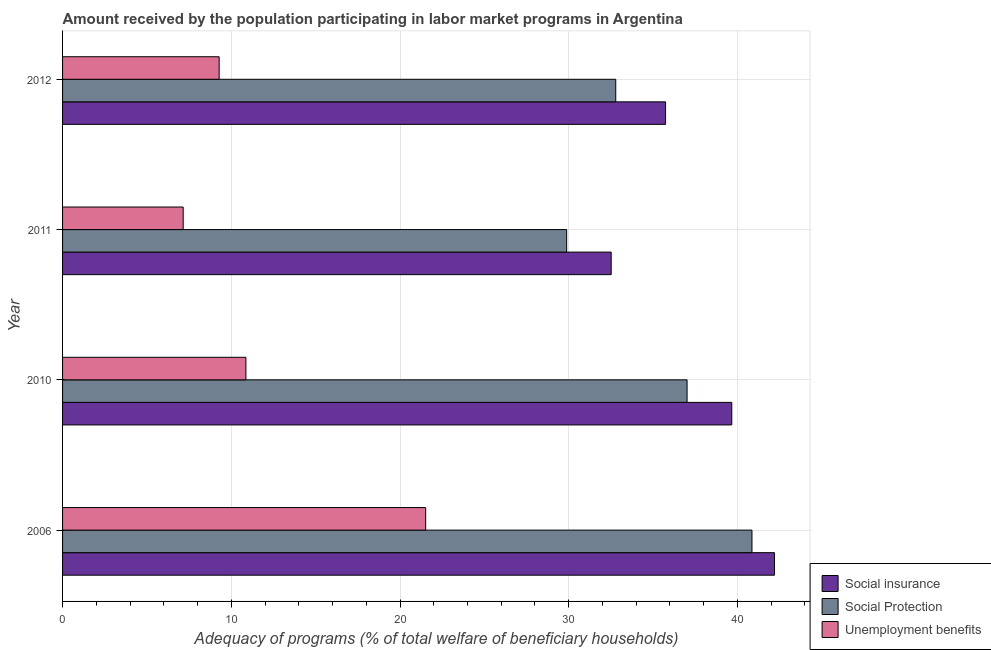How many different coloured bars are there?
Give a very brief answer. 3. Are the number of bars per tick equal to the number of legend labels?
Give a very brief answer. Yes. How many bars are there on the 4th tick from the bottom?
Keep it short and to the point. 3. What is the label of the 2nd group of bars from the top?
Give a very brief answer. 2011. What is the amount received by the population participating in social protection programs in 2006?
Provide a short and direct response. 40.86. Across all years, what is the maximum amount received by the population participating in social protection programs?
Offer a very short reply. 40.86. Across all years, what is the minimum amount received by the population participating in unemployment benefits programs?
Offer a terse response. 7.15. In which year was the amount received by the population participating in unemployment benefits programs minimum?
Ensure brevity in your answer.  2011. What is the total amount received by the population participating in unemployment benefits programs in the graph?
Offer a very short reply. 48.82. What is the difference between the amount received by the population participating in social insurance programs in 2006 and that in 2010?
Offer a terse response. 2.53. What is the difference between the amount received by the population participating in social insurance programs in 2011 and the amount received by the population participating in unemployment benefits programs in 2012?
Your answer should be very brief. 23.23. What is the average amount received by the population participating in social protection programs per year?
Keep it short and to the point. 35.13. In the year 2012, what is the difference between the amount received by the population participating in social protection programs and amount received by the population participating in social insurance programs?
Your response must be concise. -2.95. What is the ratio of the amount received by the population participating in unemployment benefits programs in 2006 to that in 2011?
Keep it short and to the point. 3.01. What is the difference between the highest and the second highest amount received by the population participating in unemployment benefits programs?
Give a very brief answer. 10.65. What is the difference between the highest and the lowest amount received by the population participating in social insurance programs?
Your response must be concise. 9.68. In how many years, is the amount received by the population participating in social insurance programs greater than the average amount received by the population participating in social insurance programs taken over all years?
Keep it short and to the point. 2. Is the sum of the amount received by the population participating in social insurance programs in 2010 and 2011 greater than the maximum amount received by the population participating in social protection programs across all years?
Ensure brevity in your answer.  Yes. What does the 1st bar from the top in 2012 represents?
Make the answer very short. Unemployment benefits. What does the 2nd bar from the bottom in 2006 represents?
Keep it short and to the point. Social Protection. Is it the case that in every year, the sum of the amount received by the population participating in social insurance programs and amount received by the population participating in social protection programs is greater than the amount received by the population participating in unemployment benefits programs?
Your answer should be very brief. Yes. How many bars are there?
Offer a terse response. 12. Are all the bars in the graph horizontal?
Make the answer very short. Yes. Where does the legend appear in the graph?
Your answer should be very brief. Bottom right. How many legend labels are there?
Ensure brevity in your answer.  3. How are the legend labels stacked?
Offer a terse response. Vertical. What is the title of the graph?
Ensure brevity in your answer.  Amount received by the population participating in labor market programs in Argentina. What is the label or title of the X-axis?
Provide a succinct answer. Adequacy of programs (% of total welfare of beneficiary households). What is the label or title of the Y-axis?
Make the answer very short. Year. What is the Adequacy of programs (% of total welfare of beneficiary households) in Social insurance in 2006?
Give a very brief answer. 42.2. What is the Adequacy of programs (% of total welfare of beneficiary households) in Social Protection in 2006?
Give a very brief answer. 40.86. What is the Adequacy of programs (% of total welfare of beneficiary households) in Unemployment benefits in 2006?
Make the answer very short. 21.52. What is the Adequacy of programs (% of total welfare of beneficiary households) in Social insurance in 2010?
Give a very brief answer. 39.66. What is the Adequacy of programs (% of total welfare of beneficiary households) in Social Protection in 2010?
Provide a succinct answer. 37.01. What is the Adequacy of programs (% of total welfare of beneficiary households) of Unemployment benefits in 2010?
Provide a succinct answer. 10.87. What is the Adequacy of programs (% of total welfare of beneficiary households) in Social insurance in 2011?
Offer a very short reply. 32.52. What is the Adequacy of programs (% of total welfare of beneficiary households) in Social Protection in 2011?
Provide a short and direct response. 29.88. What is the Adequacy of programs (% of total welfare of beneficiary households) of Unemployment benefits in 2011?
Make the answer very short. 7.15. What is the Adequacy of programs (% of total welfare of beneficiary households) in Social insurance in 2012?
Provide a short and direct response. 35.74. What is the Adequacy of programs (% of total welfare of beneficiary households) of Social Protection in 2012?
Provide a succinct answer. 32.79. What is the Adequacy of programs (% of total welfare of beneficiary households) in Unemployment benefits in 2012?
Make the answer very short. 9.28. Across all years, what is the maximum Adequacy of programs (% of total welfare of beneficiary households) in Social insurance?
Offer a terse response. 42.2. Across all years, what is the maximum Adequacy of programs (% of total welfare of beneficiary households) in Social Protection?
Your answer should be very brief. 40.86. Across all years, what is the maximum Adequacy of programs (% of total welfare of beneficiary households) in Unemployment benefits?
Ensure brevity in your answer.  21.52. Across all years, what is the minimum Adequacy of programs (% of total welfare of beneficiary households) in Social insurance?
Give a very brief answer. 32.52. Across all years, what is the minimum Adequacy of programs (% of total welfare of beneficiary households) of Social Protection?
Your answer should be compact. 29.88. Across all years, what is the minimum Adequacy of programs (% of total welfare of beneficiary households) in Unemployment benefits?
Your answer should be compact. 7.15. What is the total Adequacy of programs (% of total welfare of beneficiary households) in Social insurance in the graph?
Your answer should be compact. 150.11. What is the total Adequacy of programs (% of total welfare of beneficiary households) of Social Protection in the graph?
Make the answer very short. 140.54. What is the total Adequacy of programs (% of total welfare of beneficiary households) of Unemployment benefits in the graph?
Your response must be concise. 48.82. What is the difference between the Adequacy of programs (% of total welfare of beneficiary households) in Social insurance in 2006 and that in 2010?
Ensure brevity in your answer.  2.53. What is the difference between the Adequacy of programs (% of total welfare of beneficiary households) in Social Protection in 2006 and that in 2010?
Keep it short and to the point. 3.85. What is the difference between the Adequacy of programs (% of total welfare of beneficiary households) of Unemployment benefits in 2006 and that in 2010?
Keep it short and to the point. 10.65. What is the difference between the Adequacy of programs (% of total welfare of beneficiary households) in Social insurance in 2006 and that in 2011?
Provide a succinct answer. 9.68. What is the difference between the Adequacy of programs (% of total welfare of beneficiary households) of Social Protection in 2006 and that in 2011?
Make the answer very short. 10.98. What is the difference between the Adequacy of programs (% of total welfare of beneficiary households) of Unemployment benefits in 2006 and that in 2011?
Offer a very short reply. 14.37. What is the difference between the Adequacy of programs (% of total welfare of beneficiary households) in Social insurance in 2006 and that in 2012?
Your response must be concise. 6.46. What is the difference between the Adequacy of programs (% of total welfare of beneficiary households) in Social Protection in 2006 and that in 2012?
Give a very brief answer. 8.07. What is the difference between the Adequacy of programs (% of total welfare of beneficiary households) in Unemployment benefits in 2006 and that in 2012?
Offer a very short reply. 12.24. What is the difference between the Adequacy of programs (% of total welfare of beneficiary households) in Social insurance in 2010 and that in 2011?
Provide a succinct answer. 7.15. What is the difference between the Adequacy of programs (% of total welfare of beneficiary households) in Social Protection in 2010 and that in 2011?
Offer a terse response. 7.14. What is the difference between the Adequacy of programs (% of total welfare of beneficiary households) of Unemployment benefits in 2010 and that in 2011?
Offer a very short reply. 3.72. What is the difference between the Adequacy of programs (% of total welfare of beneficiary households) of Social insurance in 2010 and that in 2012?
Your answer should be very brief. 3.92. What is the difference between the Adequacy of programs (% of total welfare of beneficiary households) in Social Protection in 2010 and that in 2012?
Make the answer very short. 4.23. What is the difference between the Adequacy of programs (% of total welfare of beneficiary households) of Unemployment benefits in 2010 and that in 2012?
Provide a succinct answer. 1.59. What is the difference between the Adequacy of programs (% of total welfare of beneficiary households) in Social insurance in 2011 and that in 2012?
Your answer should be compact. -3.22. What is the difference between the Adequacy of programs (% of total welfare of beneficiary households) of Social Protection in 2011 and that in 2012?
Make the answer very short. -2.91. What is the difference between the Adequacy of programs (% of total welfare of beneficiary households) of Unemployment benefits in 2011 and that in 2012?
Your answer should be very brief. -2.13. What is the difference between the Adequacy of programs (% of total welfare of beneficiary households) of Social insurance in 2006 and the Adequacy of programs (% of total welfare of beneficiary households) of Social Protection in 2010?
Your answer should be very brief. 5.18. What is the difference between the Adequacy of programs (% of total welfare of beneficiary households) of Social insurance in 2006 and the Adequacy of programs (% of total welfare of beneficiary households) of Unemployment benefits in 2010?
Your answer should be very brief. 31.33. What is the difference between the Adequacy of programs (% of total welfare of beneficiary households) of Social Protection in 2006 and the Adequacy of programs (% of total welfare of beneficiary households) of Unemployment benefits in 2010?
Ensure brevity in your answer.  29.99. What is the difference between the Adequacy of programs (% of total welfare of beneficiary households) of Social insurance in 2006 and the Adequacy of programs (% of total welfare of beneficiary households) of Social Protection in 2011?
Provide a succinct answer. 12.32. What is the difference between the Adequacy of programs (% of total welfare of beneficiary households) of Social insurance in 2006 and the Adequacy of programs (% of total welfare of beneficiary households) of Unemployment benefits in 2011?
Provide a succinct answer. 35.05. What is the difference between the Adequacy of programs (% of total welfare of beneficiary households) in Social Protection in 2006 and the Adequacy of programs (% of total welfare of beneficiary households) in Unemployment benefits in 2011?
Provide a succinct answer. 33.71. What is the difference between the Adequacy of programs (% of total welfare of beneficiary households) of Social insurance in 2006 and the Adequacy of programs (% of total welfare of beneficiary households) of Social Protection in 2012?
Offer a terse response. 9.41. What is the difference between the Adequacy of programs (% of total welfare of beneficiary households) of Social insurance in 2006 and the Adequacy of programs (% of total welfare of beneficiary households) of Unemployment benefits in 2012?
Offer a terse response. 32.91. What is the difference between the Adequacy of programs (% of total welfare of beneficiary households) in Social Protection in 2006 and the Adequacy of programs (% of total welfare of beneficiary households) in Unemployment benefits in 2012?
Your response must be concise. 31.58. What is the difference between the Adequacy of programs (% of total welfare of beneficiary households) in Social insurance in 2010 and the Adequacy of programs (% of total welfare of beneficiary households) in Social Protection in 2011?
Make the answer very short. 9.79. What is the difference between the Adequacy of programs (% of total welfare of beneficiary households) in Social insurance in 2010 and the Adequacy of programs (% of total welfare of beneficiary households) in Unemployment benefits in 2011?
Offer a terse response. 32.51. What is the difference between the Adequacy of programs (% of total welfare of beneficiary households) of Social Protection in 2010 and the Adequacy of programs (% of total welfare of beneficiary households) of Unemployment benefits in 2011?
Your answer should be very brief. 29.87. What is the difference between the Adequacy of programs (% of total welfare of beneficiary households) in Social insurance in 2010 and the Adequacy of programs (% of total welfare of beneficiary households) in Social Protection in 2012?
Keep it short and to the point. 6.88. What is the difference between the Adequacy of programs (% of total welfare of beneficiary households) of Social insurance in 2010 and the Adequacy of programs (% of total welfare of beneficiary households) of Unemployment benefits in 2012?
Provide a succinct answer. 30.38. What is the difference between the Adequacy of programs (% of total welfare of beneficiary households) of Social Protection in 2010 and the Adequacy of programs (% of total welfare of beneficiary households) of Unemployment benefits in 2012?
Make the answer very short. 27.73. What is the difference between the Adequacy of programs (% of total welfare of beneficiary households) of Social insurance in 2011 and the Adequacy of programs (% of total welfare of beneficiary households) of Social Protection in 2012?
Offer a terse response. -0.27. What is the difference between the Adequacy of programs (% of total welfare of beneficiary households) in Social insurance in 2011 and the Adequacy of programs (% of total welfare of beneficiary households) in Unemployment benefits in 2012?
Offer a terse response. 23.23. What is the difference between the Adequacy of programs (% of total welfare of beneficiary households) in Social Protection in 2011 and the Adequacy of programs (% of total welfare of beneficiary households) in Unemployment benefits in 2012?
Give a very brief answer. 20.6. What is the average Adequacy of programs (% of total welfare of beneficiary households) of Social insurance per year?
Provide a short and direct response. 37.53. What is the average Adequacy of programs (% of total welfare of beneficiary households) in Social Protection per year?
Offer a terse response. 35.13. What is the average Adequacy of programs (% of total welfare of beneficiary households) in Unemployment benefits per year?
Your answer should be compact. 12.2. In the year 2006, what is the difference between the Adequacy of programs (% of total welfare of beneficiary households) in Social insurance and Adequacy of programs (% of total welfare of beneficiary households) in Social Protection?
Provide a short and direct response. 1.33. In the year 2006, what is the difference between the Adequacy of programs (% of total welfare of beneficiary households) of Social insurance and Adequacy of programs (% of total welfare of beneficiary households) of Unemployment benefits?
Keep it short and to the point. 20.67. In the year 2006, what is the difference between the Adequacy of programs (% of total welfare of beneficiary households) in Social Protection and Adequacy of programs (% of total welfare of beneficiary households) in Unemployment benefits?
Offer a terse response. 19.34. In the year 2010, what is the difference between the Adequacy of programs (% of total welfare of beneficiary households) of Social insurance and Adequacy of programs (% of total welfare of beneficiary households) of Social Protection?
Your answer should be compact. 2.65. In the year 2010, what is the difference between the Adequacy of programs (% of total welfare of beneficiary households) in Social insurance and Adequacy of programs (% of total welfare of beneficiary households) in Unemployment benefits?
Your answer should be very brief. 28.8. In the year 2010, what is the difference between the Adequacy of programs (% of total welfare of beneficiary households) in Social Protection and Adequacy of programs (% of total welfare of beneficiary households) in Unemployment benefits?
Your answer should be compact. 26.15. In the year 2011, what is the difference between the Adequacy of programs (% of total welfare of beneficiary households) in Social insurance and Adequacy of programs (% of total welfare of beneficiary households) in Social Protection?
Keep it short and to the point. 2.64. In the year 2011, what is the difference between the Adequacy of programs (% of total welfare of beneficiary households) of Social insurance and Adequacy of programs (% of total welfare of beneficiary households) of Unemployment benefits?
Keep it short and to the point. 25.37. In the year 2011, what is the difference between the Adequacy of programs (% of total welfare of beneficiary households) of Social Protection and Adequacy of programs (% of total welfare of beneficiary households) of Unemployment benefits?
Provide a short and direct response. 22.73. In the year 2012, what is the difference between the Adequacy of programs (% of total welfare of beneficiary households) of Social insurance and Adequacy of programs (% of total welfare of beneficiary households) of Social Protection?
Ensure brevity in your answer.  2.95. In the year 2012, what is the difference between the Adequacy of programs (% of total welfare of beneficiary households) of Social insurance and Adequacy of programs (% of total welfare of beneficiary households) of Unemployment benefits?
Your response must be concise. 26.46. In the year 2012, what is the difference between the Adequacy of programs (% of total welfare of beneficiary households) in Social Protection and Adequacy of programs (% of total welfare of beneficiary households) in Unemployment benefits?
Offer a terse response. 23.5. What is the ratio of the Adequacy of programs (% of total welfare of beneficiary households) of Social insurance in 2006 to that in 2010?
Provide a short and direct response. 1.06. What is the ratio of the Adequacy of programs (% of total welfare of beneficiary households) of Social Protection in 2006 to that in 2010?
Offer a terse response. 1.1. What is the ratio of the Adequacy of programs (% of total welfare of beneficiary households) in Unemployment benefits in 2006 to that in 2010?
Make the answer very short. 1.98. What is the ratio of the Adequacy of programs (% of total welfare of beneficiary households) of Social insurance in 2006 to that in 2011?
Your response must be concise. 1.3. What is the ratio of the Adequacy of programs (% of total welfare of beneficiary households) in Social Protection in 2006 to that in 2011?
Provide a short and direct response. 1.37. What is the ratio of the Adequacy of programs (% of total welfare of beneficiary households) of Unemployment benefits in 2006 to that in 2011?
Offer a very short reply. 3.01. What is the ratio of the Adequacy of programs (% of total welfare of beneficiary households) in Social insurance in 2006 to that in 2012?
Give a very brief answer. 1.18. What is the ratio of the Adequacy of programs (% of total welfare of beneficiary households) in Social Protection in 2006 to that in 2012?
Ensure brevity in your answer.  1.25. What is the ratio of the Adequacy of programs (% of total welfare of beneficiary households) of Unemployment benefits in 2006 to that in 2012?
Provide a short and direct response. 2.32. What is the ratio of the Adequacy of programs (% of total welfare of beneficiary households) of Social insurance in 2010 to that in 2011?
Keep it short and to the point. 1.22. What is the ratio of the Adequacy of programs (% of total welfare of beneficiary households) of Social Protection in 2010 to that in 2011?
Provide a succinct answer. 1.24. What is the ratio of the Adequacy of programs (% of total welfare of beneficiary households) of Unemployment benefits in 2010 to that in 2011?
Ensure brevity in your answer.  1.52. What is the ratio of the Adequacy of programs (% of total welfare of beneficiary households) in Social insurance in 2010 to that in 2012?
Provide a succinct answer. 1.11. What is the ratio of the Adequacy of programs (% of total welfare of beneficiary households) of Social Protection in 2010 to that in 2012?
Your answer should be very brief. 1.13. What is the ratio of the Adequacy of programs (% of total welfare of beneficiary households) of Unemployment benefits in 2010 to that in 2012?
Your answer should be compact. 1.17. What is the ratio of the Adequacy of programs (% of total welfare of beneficiary households) in Social insurance in 2011 to that in 2012?
Ensure brevity in your answer.  0.91. What is the ratio of the Adequacy of programs (% of total welfare of beneficiary households) in Social Protection in 2011 to that in 2012?
Make the answer very short. 0.91. What is the ratio of the Adequacy of programs (% of total welfare of beneficiary households) in Unemployment benefits in 2011 to that in 2012?
Give a very brief answer. 0.77. What is the difference between the highest and the second highest Adequacy of programs (% of total welfare of beneficiary households) of Social insurance?
Ensure brevity in your answer.  2.53. What is the difference between the highest and the second highest Adequacy of programs (% of total welfare of beneficiary households) of Social Protection?
Offer a very short reply. 3.85. What is the difference between the highest and the second highest Adequacy of programs (% of total welfare of beneficiary households) in Unemployment benefits?
Give a very brief answer. 10.65. What is the difference between the highest and the lowest Adequacy of programs (% of total welfare of beneficiary households) of Social insurance?
Your answer should be compact. 9.68. What is the difference between the highest and the lowest Adequacy of programs (% of total welfare of beneficiary households) of Social Protection?
Provide a succinct answer. 10.98. What is the difference between the highest and the lowest Adequacy of programs (% of total welfare of beneficiary households) of Unemployment benefits?
Make the answer very short. 14.37. 